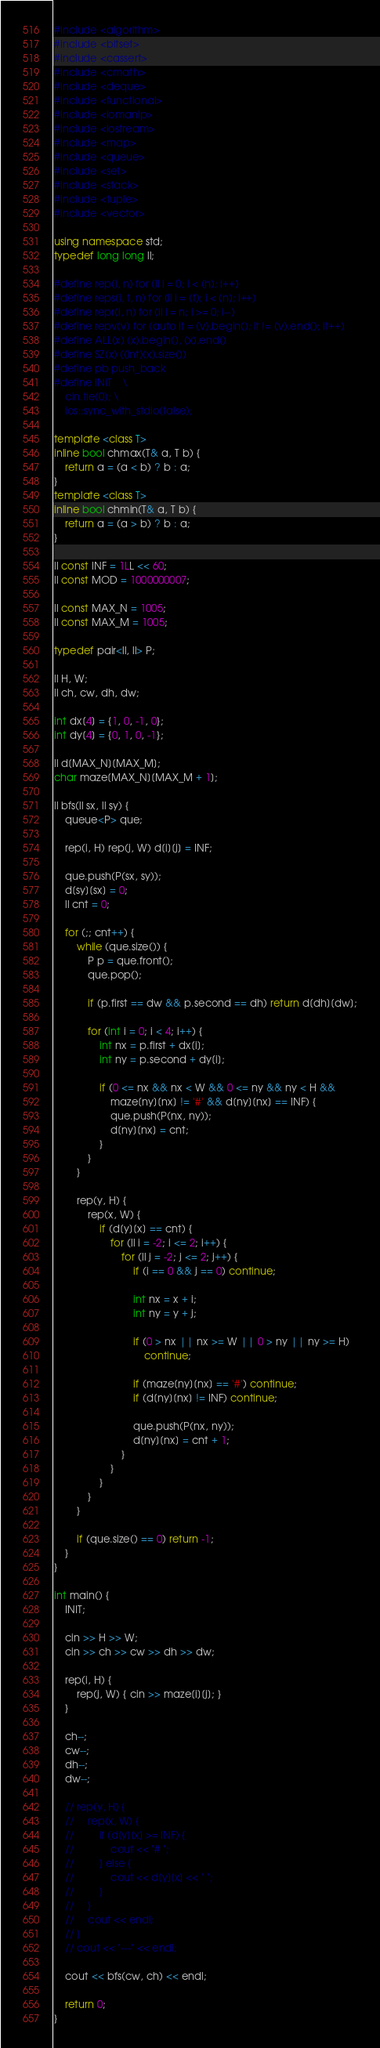<code> <loc_0><loc_0><loc_500><loc_500><_C++_>#include <algorithm>
#include <bitset>
#include <cassert>
#include <cmath>
#include <deque>
#include <functional>
#include <iomanip>
#include <iostream>
#include <map>
#include <queue>
#include <set>
#include <stack>
#include <tuple>
#include <vector>

using namespace std;
typedef long long ll;

#define rep(i, n) for (ll i = 0; i < (n); i++)
#define reps(i, f, n) for (ll i = (f); i < (n); i++)
#define repr(i, n) for (ll i = n; i >= 0; i--)
#define repv(v) for (auto it = (v).begin(); it != (v).end(); it++)
#define ALL(x) (x).begin(), (x).end()
#define SZ(x) ((int)(x).size())
#define pb push_back
#define INIT    \
    cin.tie(0); \
    ios::sync_with_stdio(false);

template <class T>
inline bool chmax(T& a, T b) {
    return a = (a < b) ? b : a;
}
template <class T>
inline bool chmin(T& a, T b) {
    return a = (a > b) ? b : a;
}

ll const INF = 1LL << 60;
ll const MOD = 1000000007;

ll const MAX_N = 1005;
ll const MAX_M = 1005;

typedef pair<ll, ll> P;

ll H, W;
ll ch, cw, dh, dw;

int dx[4] = {1, 0, -1, 0};
int dy[4] = {0, 1, 0, -1};

ll d[MAX_N][MAX_M];
char maze[MAX_N][MAX_M + 1];

ll bfs(ll sx, ll sy) {
    queue<P> que;

    rep(i, H) rep(j, W) d[i][j] = INF;

    que.push(P(sx, sy));
    d[sy][sx] = 0;
    ll cnt = 0;

    for (;; cnt++) {
        while (que.size()) {
            P p = que.front();
            que.pop();

            if (p.first == dw && p.second == dh) return d[dh][dw];

            for (int i = 0; i < 4; i++) {
                int nx = p.first + dx[i];
                int ny = p.second + dy[i];

                if (0 <= nx && nx < W && 0 <= ny && ny < H &&
                    maze[ny][nx] != '#' && d[ny][nx] == INF) {
                    que.push(P(nx, ny));
                    d[ny][nx] = cnt;
                }
            }
        }

        rep(y, H) {
            rep(x, W) {
                if (d[y][x] == cnt) {
                    for (ll i = -2; i <= 2; i++) {
                        for (ll j = -2; j <= 2; j++) {
                            if (i == 0 && j == 0) continue;

                            int nx = x + i;
                            int ny = y + j;

                            if (0 > nx || nx >= W || 0 > ny || ny >= H)
                                continue;

                            if (maze[ny][nx] == '#') continue;
                            if (d[ny][nx] != INF) continue;

                            que.push(P(nx, ny));
                            d[ny][nx] = cnt + 1;
                        }
                    }
                }
            }
        }

        if (que.size() == 0) return -1;
    }
}

int main() {
    INIT;

    cin >> H >> W;
    cin >> ch >> cw >> dh >> dw;

    rep(i, H) {
        rep(j, W) { cin >> maze[i][j]; }
    }

    ch--;
    cw--;
    dh--;
    dw--;

    // rep(y, H) {
    //     rep(x, W) {
    //         if (d[y][x] >= INF) {
    //             cout << "# ";
    //         } else {
    //             cout << d[y][x] << " ";
    //         }
    //     }
    //     cout << endl;
    // }
    // cout << "---" << endl;

    cout << bfs(cw, ch) << endl;

    return 0;
}</code> 